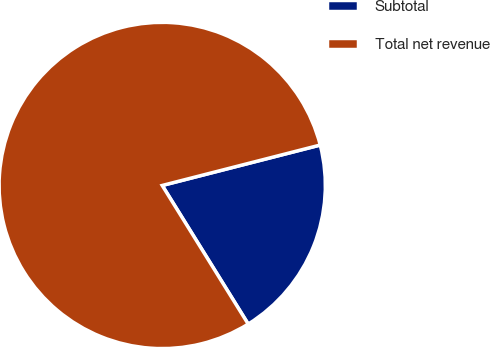Convert chart. <chart><loc_0><loc_0><loc_500><loc_500><pie_chart><fcel>Subtotal<fcel>Total net revenue<nl><fcel>20.15%<fcel>79.85%<nl></chart> 